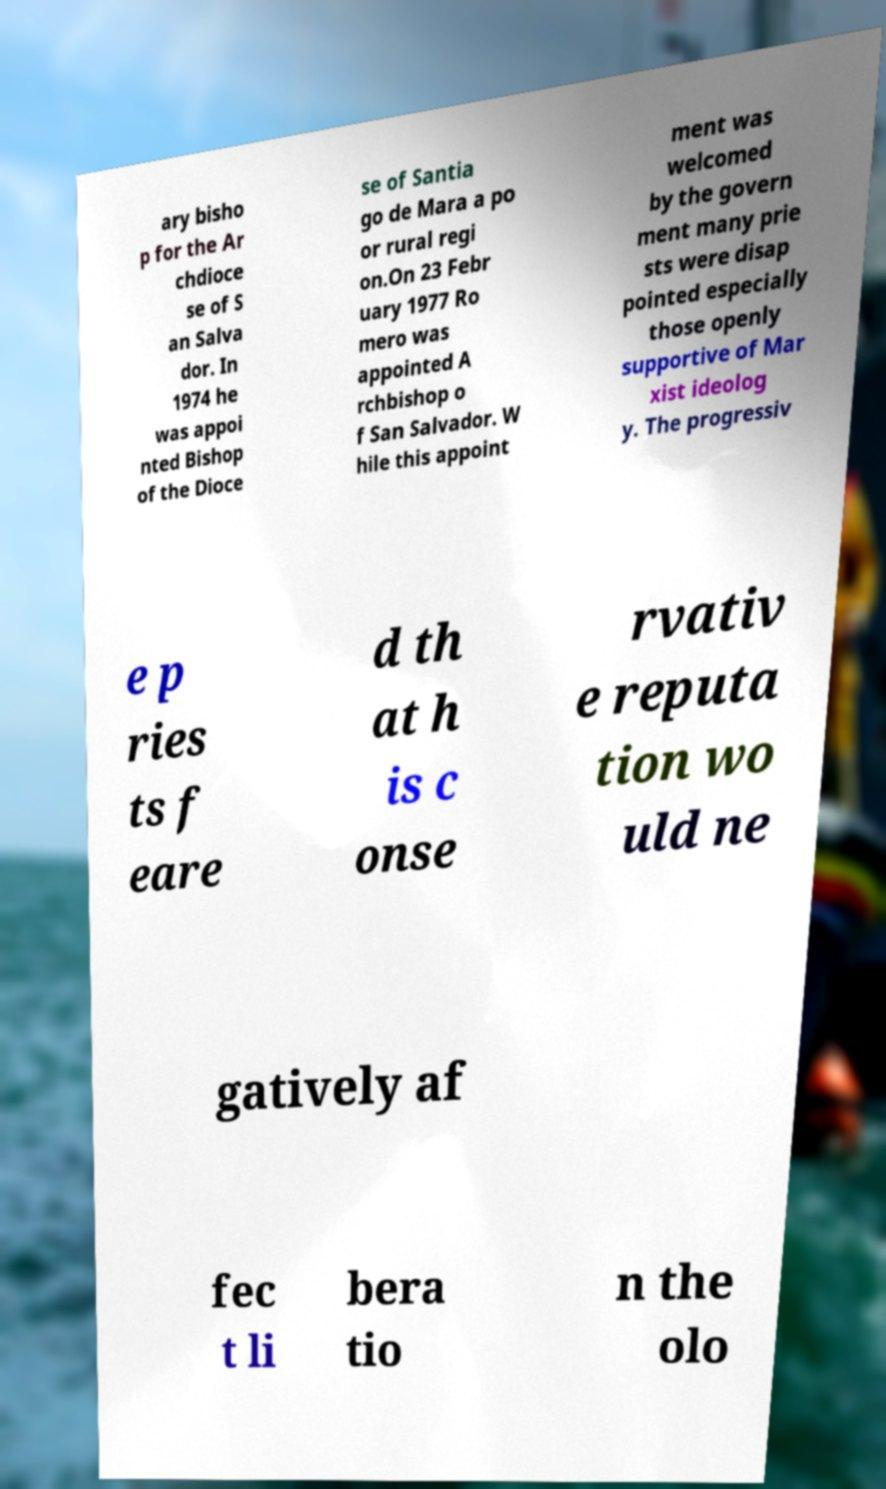Please identify and transcribe the text found in this image. ary bisho p for the Ar chdioce se of S an Salva dor. In 1974 he was appoi nted Bishop of the Dioce se of Santia go de Mara a po or rural regi on.On 23 Febr uary 1977 Ro mero was appointed A rchbishop o f San Salvador. W hile this appoint ment was welcomed by the govern ment many prie sts were disap pointed especially those openly supportive of Mar xist ideolog y. The progressiv e p ries ts f eare d th at h is c onse rvativ e reputa tion wo uld ne gatively af fec t li bera tio n the olo 